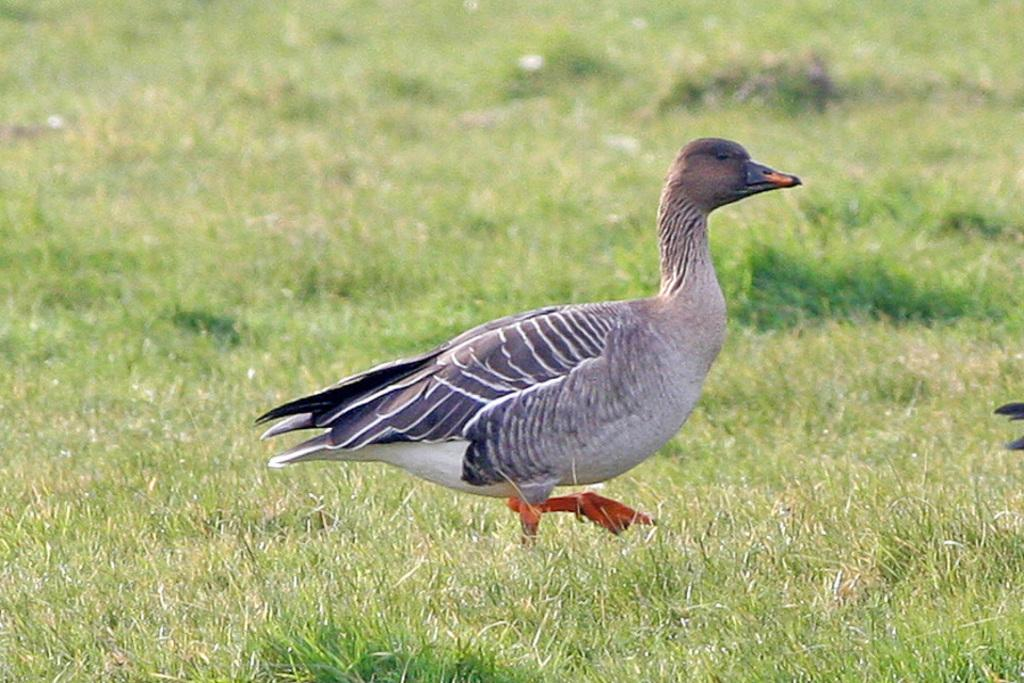What type of animal can be seen in the image? There is a bird in the image. What can be seen in the background of the image? There is grass in the background of the image. Can you describe the object on the right side of the image? Unfortunately, the facts provided do not give enough information to describe the object on the right side of the image. What type of attraction is the bird visiting in the image? There is no indication in the image that the bird is visiting an attraction, as it is simply a bird in its natural environment. 